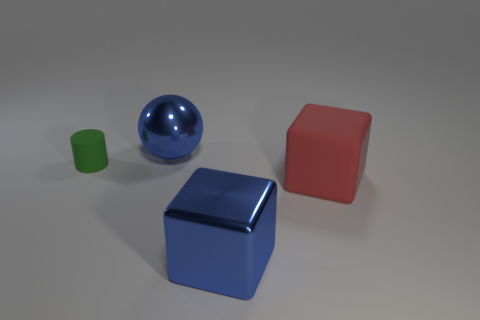Are there any other things that have the same size as the green cylinder?
Give a very brief answer. No. There is a blue thing behind the small green matte cylinder; what is it made of?
Ensure brevity in your answer.  Metal. The small matte thing is what color?
Offer a very short reply. Green. Does the blue shiny thing that is in front of the matte cylinder have the same size as the blue metal object that is behind the small green thing?
Your response must be concise. Yes. There is a thing that is on the right side of the small green rubber cylinder and to the left of the big metallic block; what size is it?
Offer a very short reply. Large. Is the number of blue things on the left side of the big blue metal block greater than the number of rubber things in front of the green object?
Your answer should be very brief. No. What number of other things are there of the same shape as the red thing?
Give a very brief answer. 1. Is there a metal cube on the right side of the large metal thing that is behind the green matte thing?
Your response must be concise. Yes. How many blue metallic spheres are there?
Keep it short and to the point. 1. There is a large shiny cube; is it the same color as the big shiny thing behind the red rubber cube?
Provide a succinct answer. Yes. 